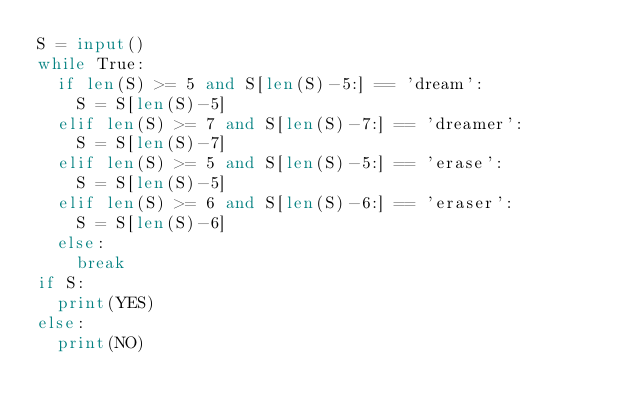<code> <loc_0><loc_0><loc_500><loc_500><_Python_>S = input()
while True:
  if len(S) >= 5 and S[len(S)-5:] == 'dream':
    S = S[len(S)-5]
  elif len(S) >= 7 and S[len(S)-7:] == 'dreamer':
    S = S[len(S)-7]
  elif len(S) >= 5 and S[len(S)-5:] == 'erase':
    S = S[len(S)-5]
  elif len(S) >= 6 and S[len(S)-6:] == 'eraser':
    S = S[len(S)-6]
  else:
    break
if S:
  print(YES)
else:
  print(NO)
</code> 